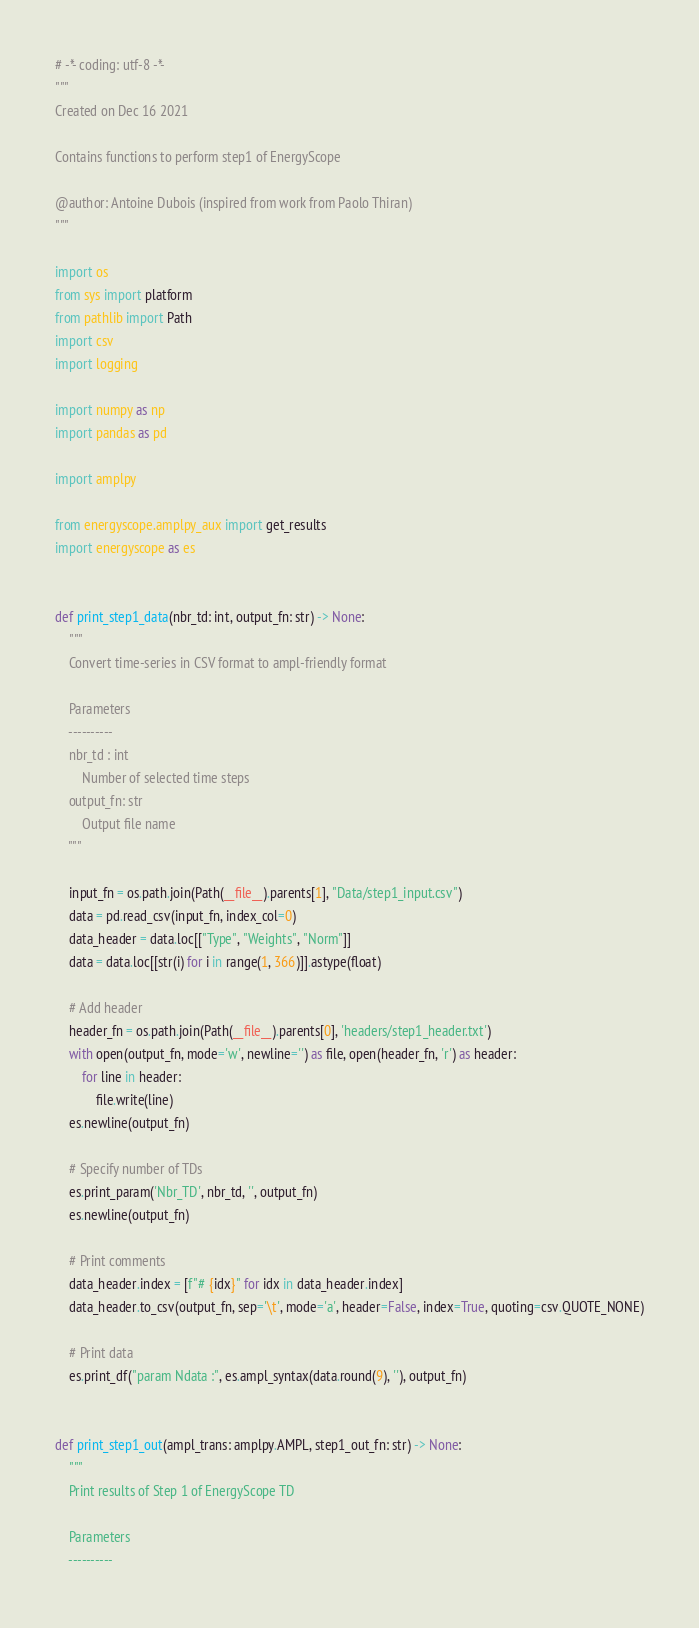Convert code to text. <code><loc_0><loc_0><loc_500><loc_500><_Python_># -*- coding: utf-8 -*-
"""
Created on Dec 16 2021

Contains functions to perform step1 of EnergyScope

@author: Antoine Dubois (inspired from work from Paolo Thiran)
"""

import os
from sys import platform
from pathlib import Path
import csv
import logging

import numpy as np
import pandas as pd

import amplpy

from energyscope.amplpy_aux import get_results
import energyscope as es


def print_step1_data(nbr_td: int, output_fn: str) -> None:
    """
    Convert time-series in CSV format to ampl-friendly format

    Parameters
    ----------
    nbr_td : int
        Number of selected time steps
    output_fn: str
        Output file name
    """

    input_fn = os.path.join(Path(__file__).parents[1], "Data/step1_input.csv")
    data = pd.read_csv(input_fn, index_col=0)
    data_header = data.loc[["Type", "Weights", "Norm"]]
    data = data.loc[[str(i) for i in range(1, 366)]].astype(float)

    # Add header
    header_fn = os.path.join(Path(__file__).parents[0], 'headers/step1_header.txt')
    with open(output_fn, mode='w', newline='') as file, open(header_fn, 'r') as header:
        for line in header:
            file.write(line)
    es.newline(output_fn)

    # Specify number of TDs
    es.print_param('Nbr_TD', nbr_td, '', output_fn)
    es.newline(output_fn)

    # Print comments
    data_header.index = [f"# {idx}" for idx in data_header.index]
    data_header.to_csv(output_fn, sep='\t', mode='a', header=False, index=True, quoting=csv.QUOTE_NONE)

    # Print data
    es.print_df("param Ndata :", es.ampl_syntax(data.round(9), ''), output_fn)


def print_step1_out(ampl_trans: amplpy.AMPL, step1_out_fn: str) -> None:
    """
    Print results of Step 1 of EnergyScope TD

    Parameters
    ----------</code> 